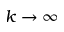<formula> <loc_0><loc_0><loc_500><loc_500>k \rightarrow \infty</formula> 